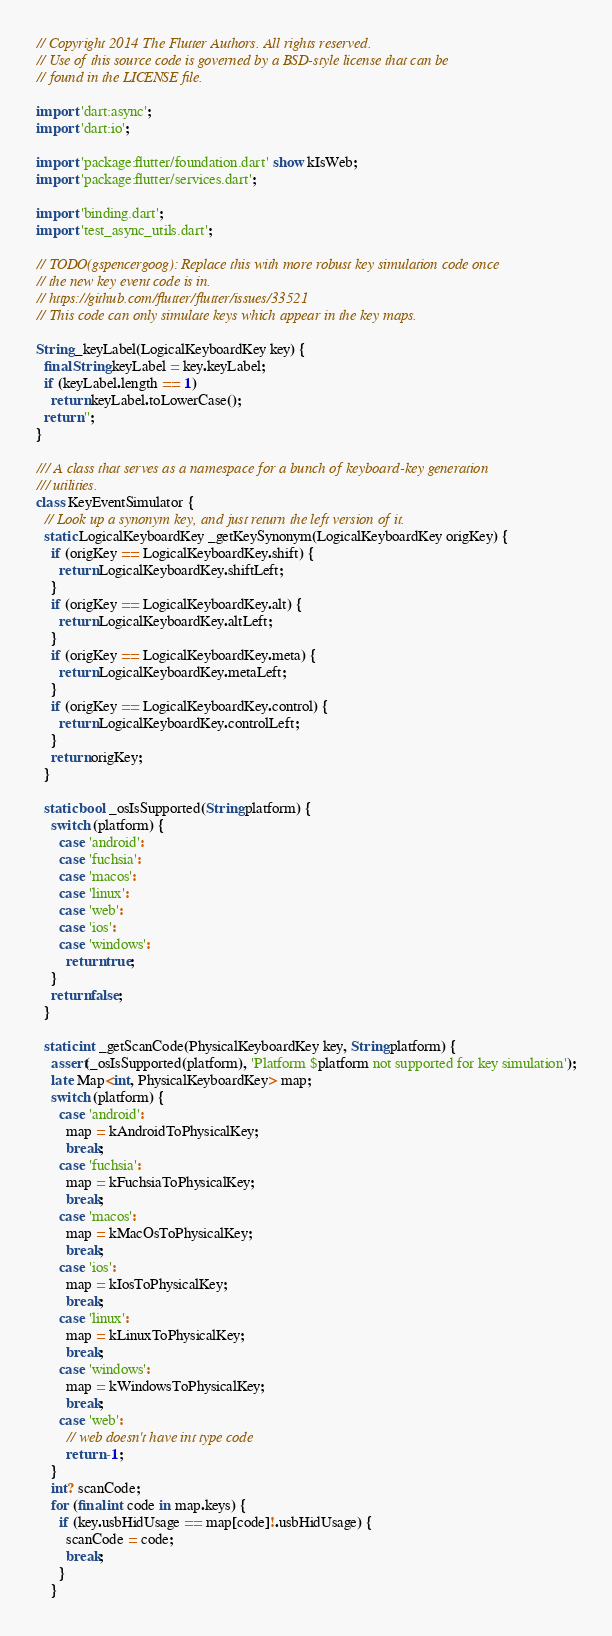<code> <loc_0><loc_0><loc_500><loc_500><_Dart_>// Copyright 2014 The Flutter Authors. All rights reserved.
// Use of this source code is governed by a BSD-style license that can be
// found in the LICENSE file.

import 'dart:async';
import 'dart:io';

import 'package:flutter/foundation.dart' show kIsWeb;
import 'package:flutter/services.dart';

import 'binding.dart';
import 'test_async_utils.dart';

// TODO(gspencergoog): Replace this with more robust key simulation code once
// the new key event code is in.
// https://github.com/flutter/flutter/issues/33521
// This code can only simulate keys which appear in the key maps.

String _keyLabel(LogicalKeyboardKey key) {
  final String keyLabel = key.keyLabel;
  if (keyLabel.length == 1)
    return keyLabel.toLowerCase();
  return '';
}

/// A class that serves as a namespace for a bunch of keyboard-key generation
/// utilities.
class KeyEventSimulator {
  // Look up a synonym key, and just return the left version of it.
  static LogicalKeyboardKey _getKeySynonym(LogicalKeyboardKey origKey) {
    if (origKey == LogicalKeyboardKey.shift) {
      return LogicalKeyboardKey.shiftLeft;
    }
    if (origKey == LogicalKeyboardKey.alt) {
      return LogicalKeyboardKey.altLeft;
    }
    if (origKey == LogicalKeyboardKey.meta) {
      return LogicalKeyboardKey.metaLeft;
    }
    if (origKey == LogicalKeyboardKey.control) {
      return LogicalKeyboardKey.controlLeft;
    }
    return origKey;
  }

  static bool _osIsSupported(String platform) {
    switch (platform) {
      case 'android':
      case 'fuchsia':
      case 'macos':
      case 'linux':
      case 'web':
      case 'ios':
      case 'windows':
        return true;
    }
    return false;
  }

  static int _getScanCode(PhysicalKeyboardKey key, String platform) {
    assert(_osIsSupported(platform), 'Platform $platform not supported for key simulation');
    late Map<int, PhysicalKeyboardKey> map;
    switch (platform) {
      case 'android':
        map = kAndroidToPhysicalKey;
        break;
      case 'fuchsia':
        map = kFuchsiaToPhysicalKey;
        break;
      case 'macos':
        map = kMacOsToPhysicalKey;
        break;
      case 'ios':
        map = kIosToPhysicalKey;
        break;
      case 'linux':
        map = kLinuxToPhysicalKey;
        break;
      case 'windows':
        map = kWindowsToPhysicalKey;
        break;
      case 'web':
        // web doesn't have int type code
        return -1;
    }
    int? scanCode;
    for (final int code in map.keys) {
      if (key.usbHidUsage == map[code]!.usbHidUsage) {
        scanCode = code;
        break;
      }
    }</code> 